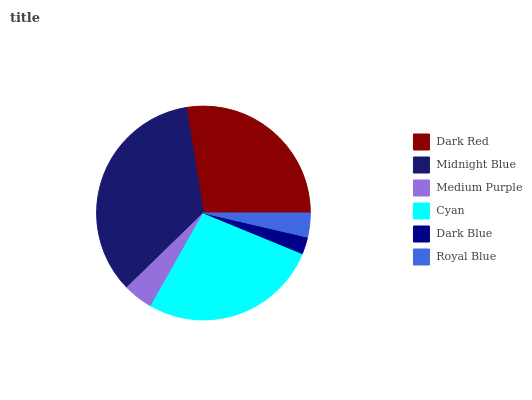Is Dark Blue the minimum?
Answer yes or no. Yes. Is Midnight Blue the maximum?
Answer yes or no. Yes. Is Medium Purple the minimum?
Answer yes or no. No. Is Medium Purple the maximum?
Answer yes or no. No. Is Midnight Blue greater than Medium Purple?
Answer yes or no. Yes. Is Medium Purple less than Midnight Blue?
Answer yes or no. Yes. Is Medium Purple greater than Midnight Blue?
Answer yes or no. No. Is Midnight Blue less than Medium Purple?
Answer yes or no. No. Is Cyan the high median?
Answer yes or no. Yes. Is Medium Purple the low median?
Answer yes or no. Yes. Is Midnight Blue the high median?
Answer yes or no. No. Is Midnight Blue the low median?
Answer yes or no. No. 